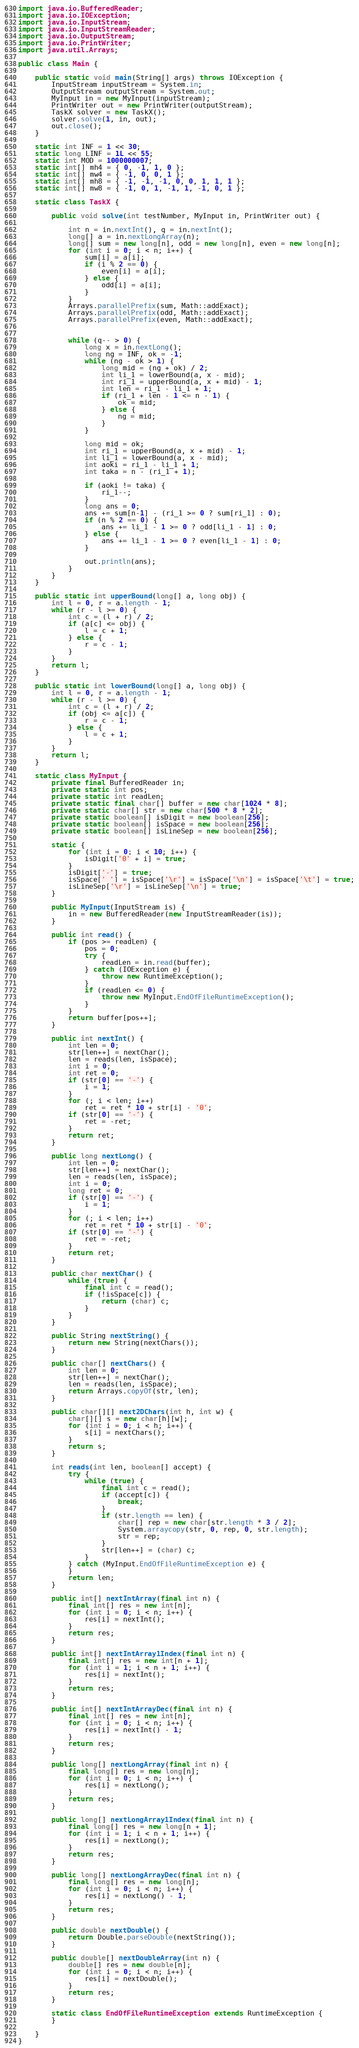Convert code to text. <code><loc_0><loc_0><loc_500><loc_500><_Java_>import java.io.BufferedReader;
import java.io.IOException;
import java.io.InputStream;
import java.io.InputStreamReader;
import java.io.OutputStream;
import java.io.PrintWriter;
import java.util.Arrays;

public class Main {

	public static void main(String[] args) throws IOException {
		InputStream inputStream = System.in;
		OutputStream outputStream = System.out;
		MyInput in = new MyInput(inputStream);
		PrintWriter out = new PrintWriter(outputStream);
		TaskX solver = new TaskX();
		solver.solve(1, in, out);
		out.close();
	}

	static int INF = 1 << 30;
	static long LINF = 1L << 55;
	static int MOD = 1000000007;
	static int[] mh4 = { 0, -1, 1, 0 };
	static int[] mw4 = { -1, 0, 0, 1 };
	static int[] mh8 = { -1, -1, -1, 0, 0, 1, 1, 1 };
	static int[] mw8 = { -1, 0, 1, -1, 1, -1, 0, 1 };

	static class TaskX {

		public void solve(int testNumber, MyInput in, PrintWriter out) {

			int n = in.nextInt(), q = in.nextInt();
			long[] a = in.nextLongArray(n);
			long[] sum = new long[n], odd = new long[n], even = new long[n];
			for (int i = 0; i < n; i++) {
				sum[i] = a[i];
				if (i % 2 == 0) {
					even[i] = a[i];
				} else {
					odd[i] = a[i];
				}
			}
			Arrays.parallelPrefix(sum, Math::addExact);
			Arrays.parallelPrefix(odd, Math::addExact);
			Arrays.parallelPrefix(even, Math::addExact);


			while (q-- > 0) {
				long x = in.nextLong();
				long ng = INF, ok = -1;
				while (ng - ok > 1) {
					long mid = (ng + ok) / 2;
					int li_1 = lowerBound(a, x - mid);
					int ri_1 = upperBound(a, x + mid) - 1;
					int len = ri_1 - li_1 + 1;
					if (ri_1 + len - 1 <= n - 1) {
						ok = mid;
					} else {
						ng = mid;
					}
				}

				long mid = ok;
				int ri_1 = upperBound(a, x + mid) - 1;
				int li_1 = lowerBound(a, x - mid);
				int aoki = ri_1 - li_1 + 1;
				int taka = n - (ri_1 + 1);

				if (aoki != taka) {
					ri_1--;
				}
				long ans = 0;
				ans += sum[n-1] - (ri_1 >= 0 ? sum[ri_1] : 0);
				if (n % 2 == 0) {
					ans += li_1 - 1 >= 0 ? odd[li_1 - 1] : 0;
				} else {
					ans += li_1 - 1 >= 0 ? even[li_1 - 1] : 0;
				}

				out.println(ans);
			}
		}
	}

	public static int upperBound(long[] a, long obj) {
		int l = 0, r = a.length - 1;
		while (r - l >= 0) {
			int c = (l + r) / 2;
			if (a[c] <= obj) {
				l = c + 1;
			} else {
				r = c - 1;
			}
		}
		return l;
	}

	public static int lowerBound(long[] a, long obj) {
		int l = 0, r = a.length - 1;
		while (r - l >= 0) {
			int c = (l + r) / 2;
			if (obj <= a[c]) {
				r = c - 1;
			} else {
				l = c + 1;
			}
		}
		return l;
	}

	static class MyInput {
		private final BufferedReader in;
		private static int pos;
		private static int readLen;
		private static final char[] buffer = new char[1024 * 8];
		private static char[] str = new char[500 * 8 * 2];
		private static boolean[] isDigit = new boolean[256];
		private static boolean[] isSpace = new boolean[256];
		private static boolean[] isLineSep = new boolean[256];

		static {
			for (int i = 0; i < 10; i++) {
				isDigit['0' + i] = true;
			}
			isDigit['-'] = true;
			isSpace[' '] = isSpace['\r'] = isSpace['\n'] = isSpace['\t'] = true;
			isLineSep['\r'] = isLineSep['\n'] = true;
		}

		public MyInput(InputStream is) {
			in = new BufferedReader(new InputStreamReader(is));
		}

		public int read() {
			if (pos >= readLen) {
				pos = 0;
				try {
					readLen = in.read(buffer);
				} catch (IOException e) {
					throw new RuntimeException();
				}
				if (readLen <= 0) {
					throw new MyInput.EndOfFileRuntimeException();
				}
			}
			return buffer[pos++];
		}

		public int nextInt() {
			int len = 0;
			str[len++] = nextChar();
			len = reads(len, isSpace);
			int i = 0;
			int ret = 0;
			if (str[0] == '-') {
				i = 1;
			}
			for (; i < len; i++)
				ret = ret * 10 + str[i] - '0';
			if (str[0] == '-') {
				ret = -ret;
			}
			return ret;
		}

		public long nextLong() {
			int len = 0;
			str[len++] = nextChar();
			len = reads(len, isSpace);
			int i = 0;
			long ret = 0;
			if (str[0] == '-') {
				i = 1;
			}
			for (; i < len; i++)
				ret = ret * 10 + str[i] - '0';
			if (str[0] == '-') {
				ret = -ret;
			}
			return ret;
		}

		public char nextChar() {
			while (true) {
				final int c = read();
				if (!isSpace[c]) {
					return (char) c;
				}
			}
		}

		public String nextString() {
			return new String(nextChars());
		}

		public char[] nextChars() {
			int len = 0;
			str[len++] = nextChar();
			len = reads(len, isSpace);
			return Arrays.copyOf(str, len);
		}

		public char[][] next2DChars(int h, int w) {
			char[][] s = new char[h][w];
			for (int i = 0; i < h; i++) {
				s[i] = nextChars();
			}
			return s;
		}

		int reads(int len, boolean[] accept) {
			try {
				while (true) {
					final int c = read();
					if (accept[c]) {
						break;
					}
					if (str.length == len) {
						char[] rep = new char[str.length * 3 / 2];
						System.arraycopy(str, 0, rep, 0, str.length);
						str = rep;
					}
					str[len++] = (char) c;
				}
			} catch (MyInput.EndOfFileRuntimeException e) {
			}
			return len;
		}

		public int[] nextIntArray(final int n) {
			final int[] res = new int[n];
			for (int i = 0; i < n; i++) {
				res[i] = nextInt();
			}
			return res;
		}

		public int[] nextIntArray1Index(final int n) {
			final int[] res = new int[n + 1];
			for (int i = 1; i < n + 1; i++) {
				res[i] = nextInt();
			}
			return res;
		}

		public int[] nextIntArrayDec(final int n) {
			final int[] res = new int[n];
			for (int i = 0; i < n; i++) {
				res[i] = nextInt() - 1;
			}
			return res;
		}

		public long[] nextLongArray(final int n) {
			final long[] res = new long[n];
			for (int i = 0; i < n; i++) {
				res[i] = nextLong();
			}
			return res;
		}

		public long[] nextLongArray1Index(final int n) {
			final long[] res = new long[n + 1];
			for (int i = 1; i < n + 1; i++) {
				res[i] = nextLong();
			}
			return res;
		}

		public long[] nextLongArrayDec(final int n) {
			final long[] res = new long[n];
			for (int i = 0; i < n; i++) {
				res[i] = nextLong() - 1;
			}
			return res;
		}

		public double nextDouble() {
			return Double.parseDouble(nextString());
		}

		public double[] nextDoubleArray(int n) {
			double[] res = new double[n];
			for (int i = 0; i < n; i++) {
				res[i] = nextDouble();
			}
			return res;
		}

		static class EndOfFileRuntimeException extends RuntimeException {
		}

	}
}
</code> 